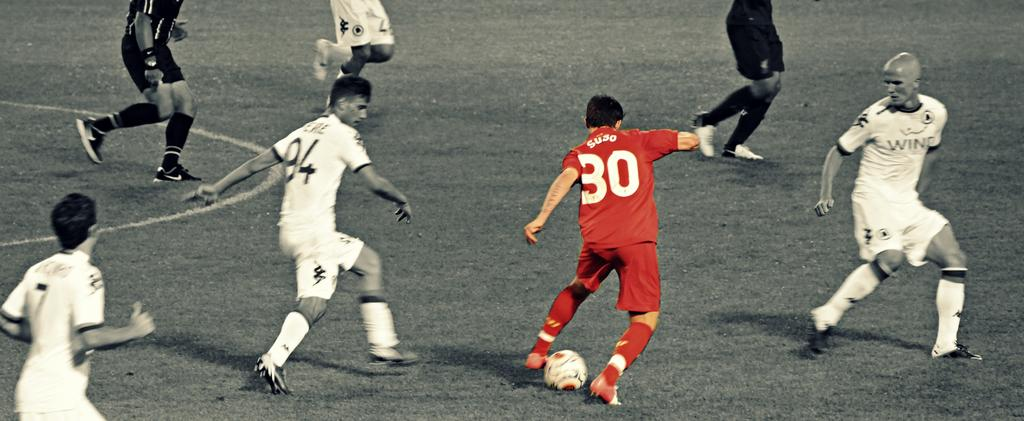<image>
Present a compact description of the photo's key features. Man in a red number 30 jersey kicking a soccer ball. 